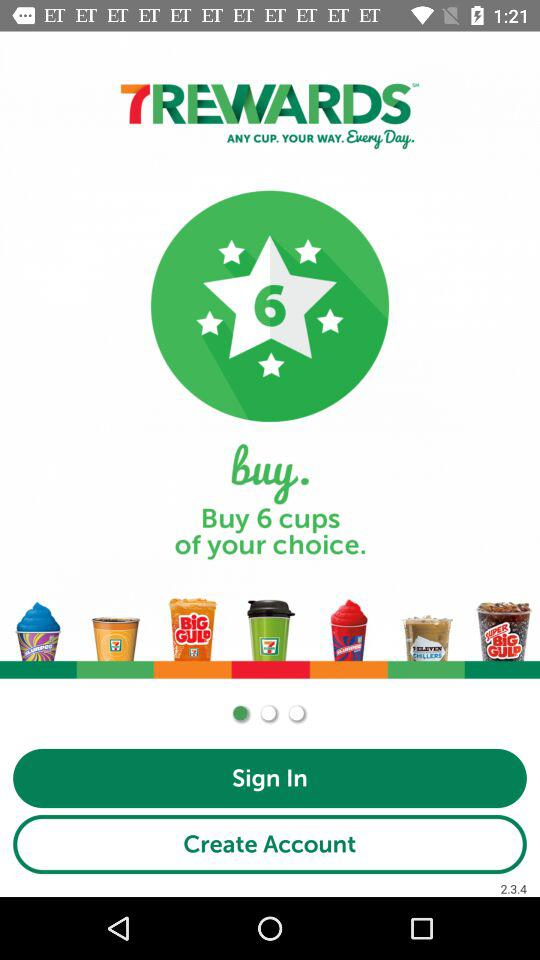What is the application name? The name of the application is "7REWARDS™". 